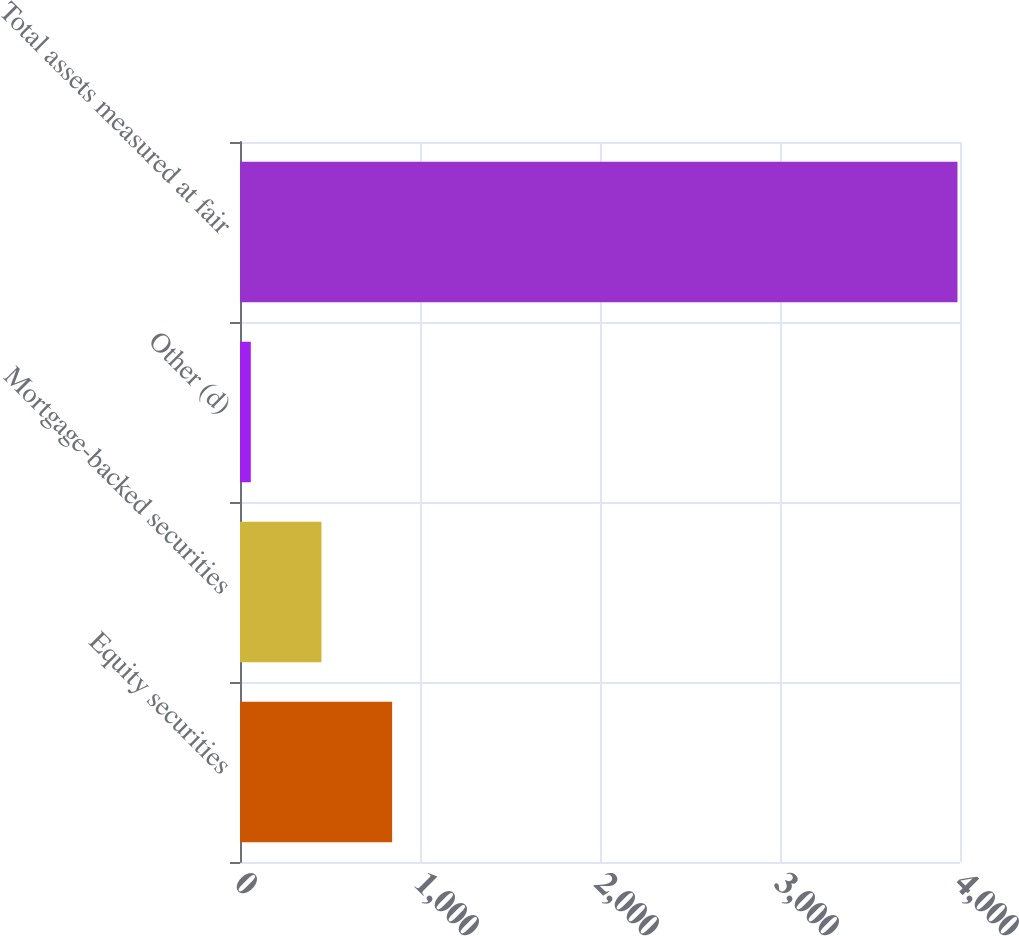<chart> <loc_0><loc_0><loc_500><loc_500><bar_chart><fcel>Equity securities<fcel>Mortgage-backed securities<fcel>Other (d)<fcel>Total assets measured at fair<nl><fcel>845.2<fcel>452.6<fcel>60<fcel>3986<nl></chart> 